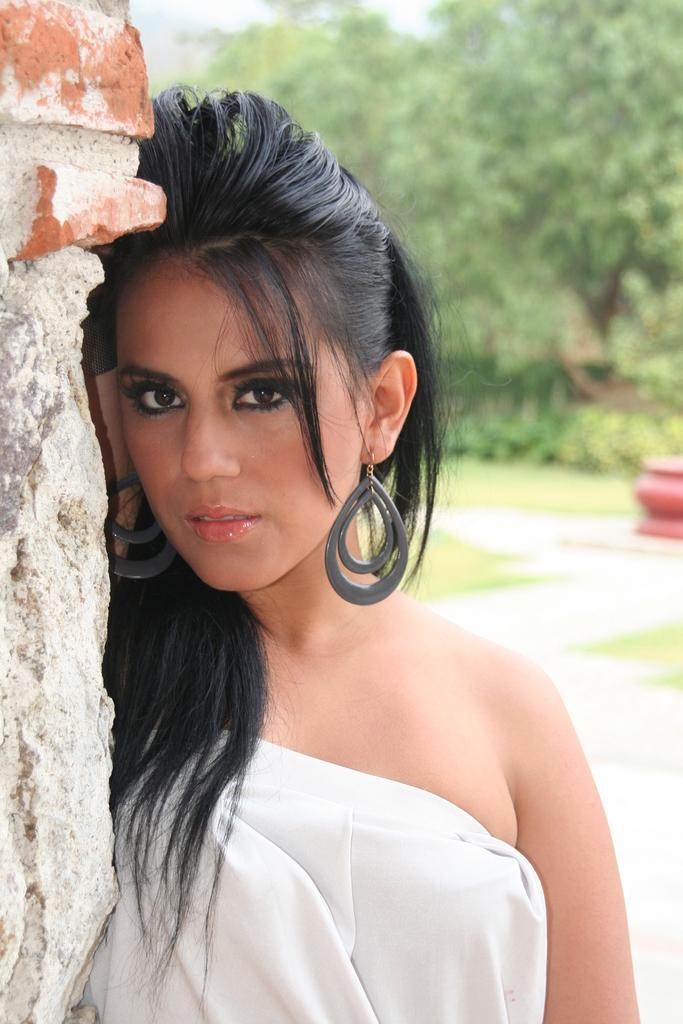Who is present in the image? There is a woman in the image. What is the woman's position in relation to the wall? The woman is standing beside a wall. What can be seen in the background of the image? There are trees and the sky visible in the background of the image. What type of camp can be seen in the image? There is no camp present in the image; it features a woman standing beside a wall with trees and the sky visible in the background. 